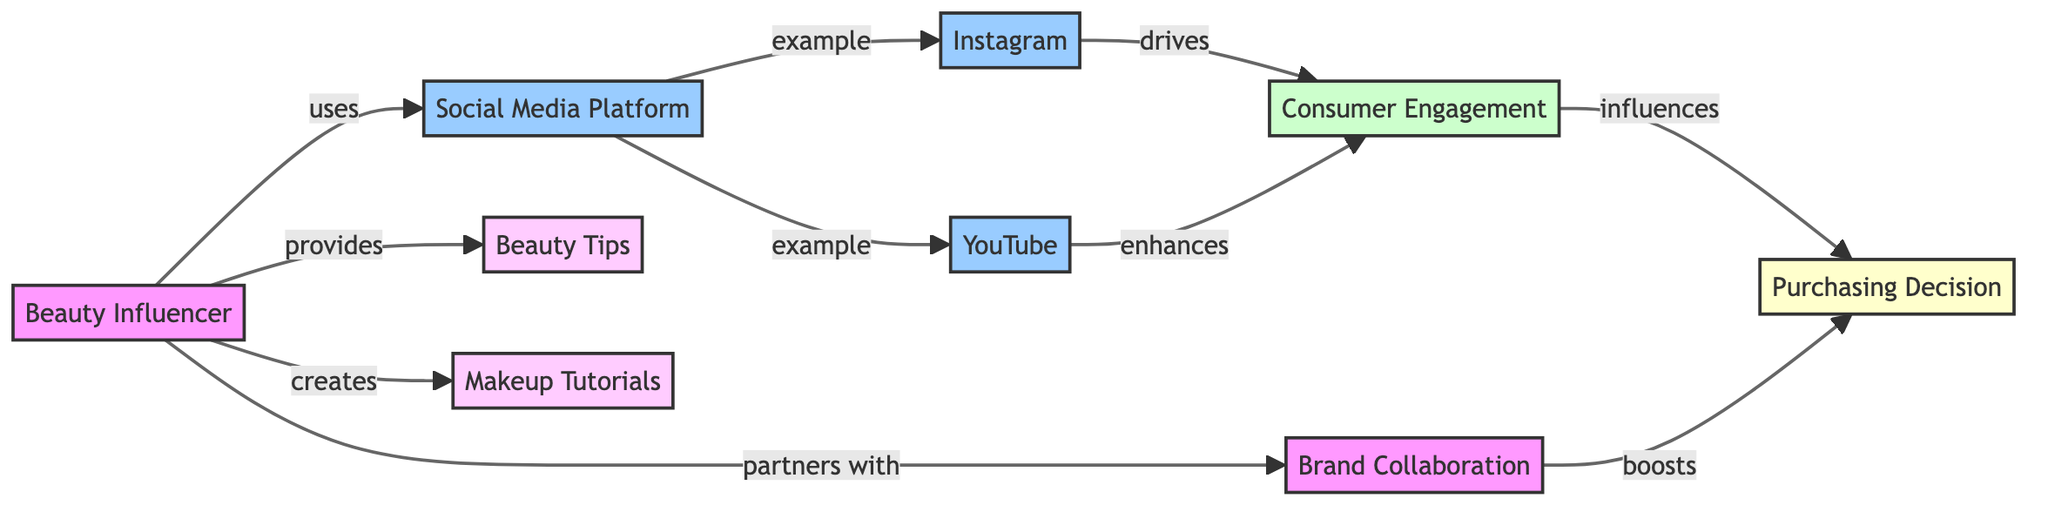What is the primary source of consumer engagement according to the diagram? The diagram indicates that both Instagram and YouTube drive consumer engagement. However, since the question asks for the primary source, one might focus on Instagram, which is shown first in the flowchart.
Answer: Instagram How many types of content does the beauty influencer provide? The diagram delineates two specific content types provided by the beauty influencer: Beauty Tips and Makeup Tutorials. Therefore, to find the answer, we count these two distinct nodes.
Answer: 2 What role do brand collaborations play in the purchasing decision? The diagram shows that brand collaborations boost the purchasing decision. Thus, to answer this question, we identify that this connection exists between the brand collaboration and the purchasing decision node.
Answer: Boosts Which social media platform enhances consumer engagement the most? According to the diagram, YouTube enhances consumer engagement in addition to Instagram. Since this question is about what enhances it the most, we identify that both are present, but the wording may indicate preference for YouTube due to its additional role of enhancement.
Answer: YouTube What is the final outcome influenced by consumer engagement? The diagram explicitly states that consumer engagement influences the purchasing decision. Thus, the answer is straightforward as it directly follows from the flow of the diagram.
Answer: Purchasing Decision Which entity partners with the beauty influencer? The diagram illustrates that the beauty influencer partners with brands, indicating the nature of the collaboration. Therefore, the direct answer would be based on this relationship depicted in the diagram.
Answer: Brands What type of content is not mentioned in the diagram? Analyzing the nodes in the diagram shows specific content types as Beauty Tips and Makeup Tutorials. Any content type that does not appear in this flowchart is not mentioned. For instance, skincare routines are absent, which provides the answer.
Answer: Skincare Routines How many relationships does the beauty influencer have with social media platforms? In the diagram, the beauty influencer has relationships with two social media platforms (Instagram and YouTube), branching from the single node of Social Media Platform. Thus, counting these relationships leads us to the answer.
Answer: 2 